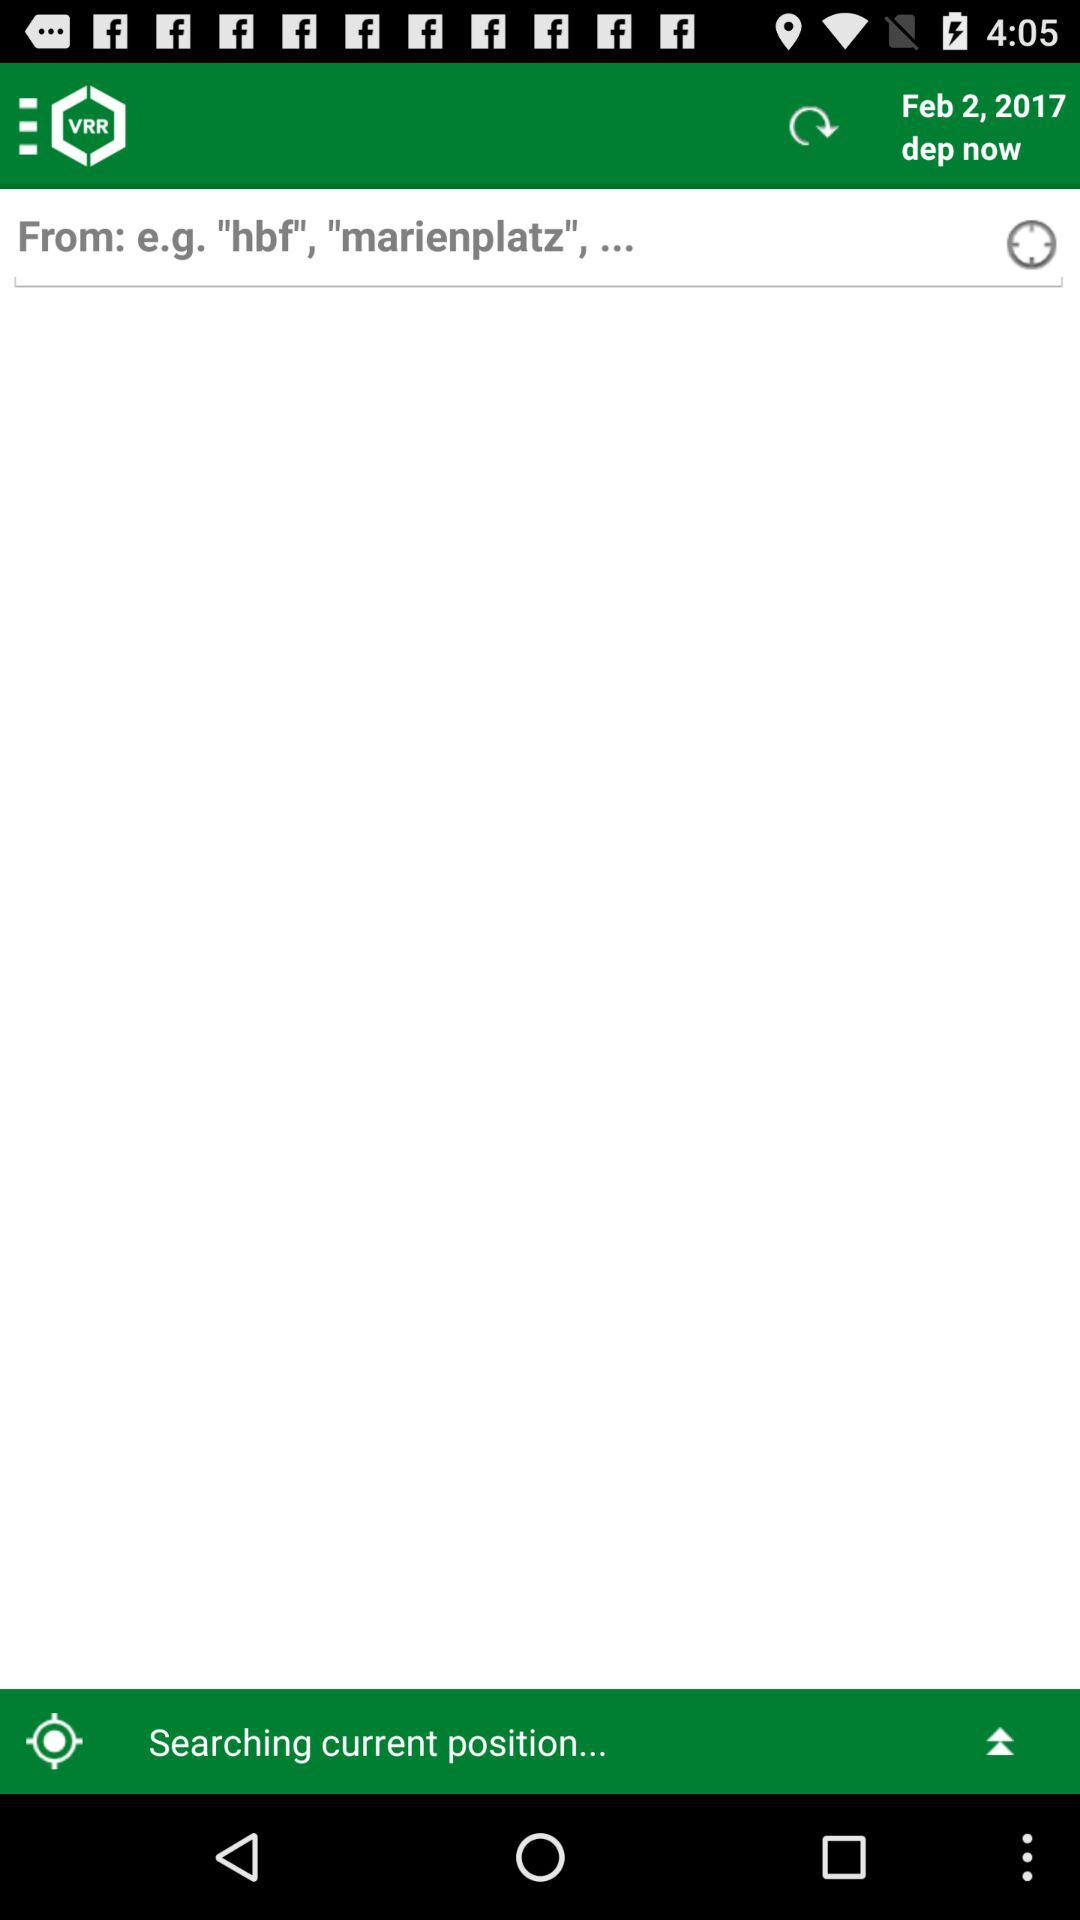What is the mentioned date? The mentioned date is February 2, 2017. 